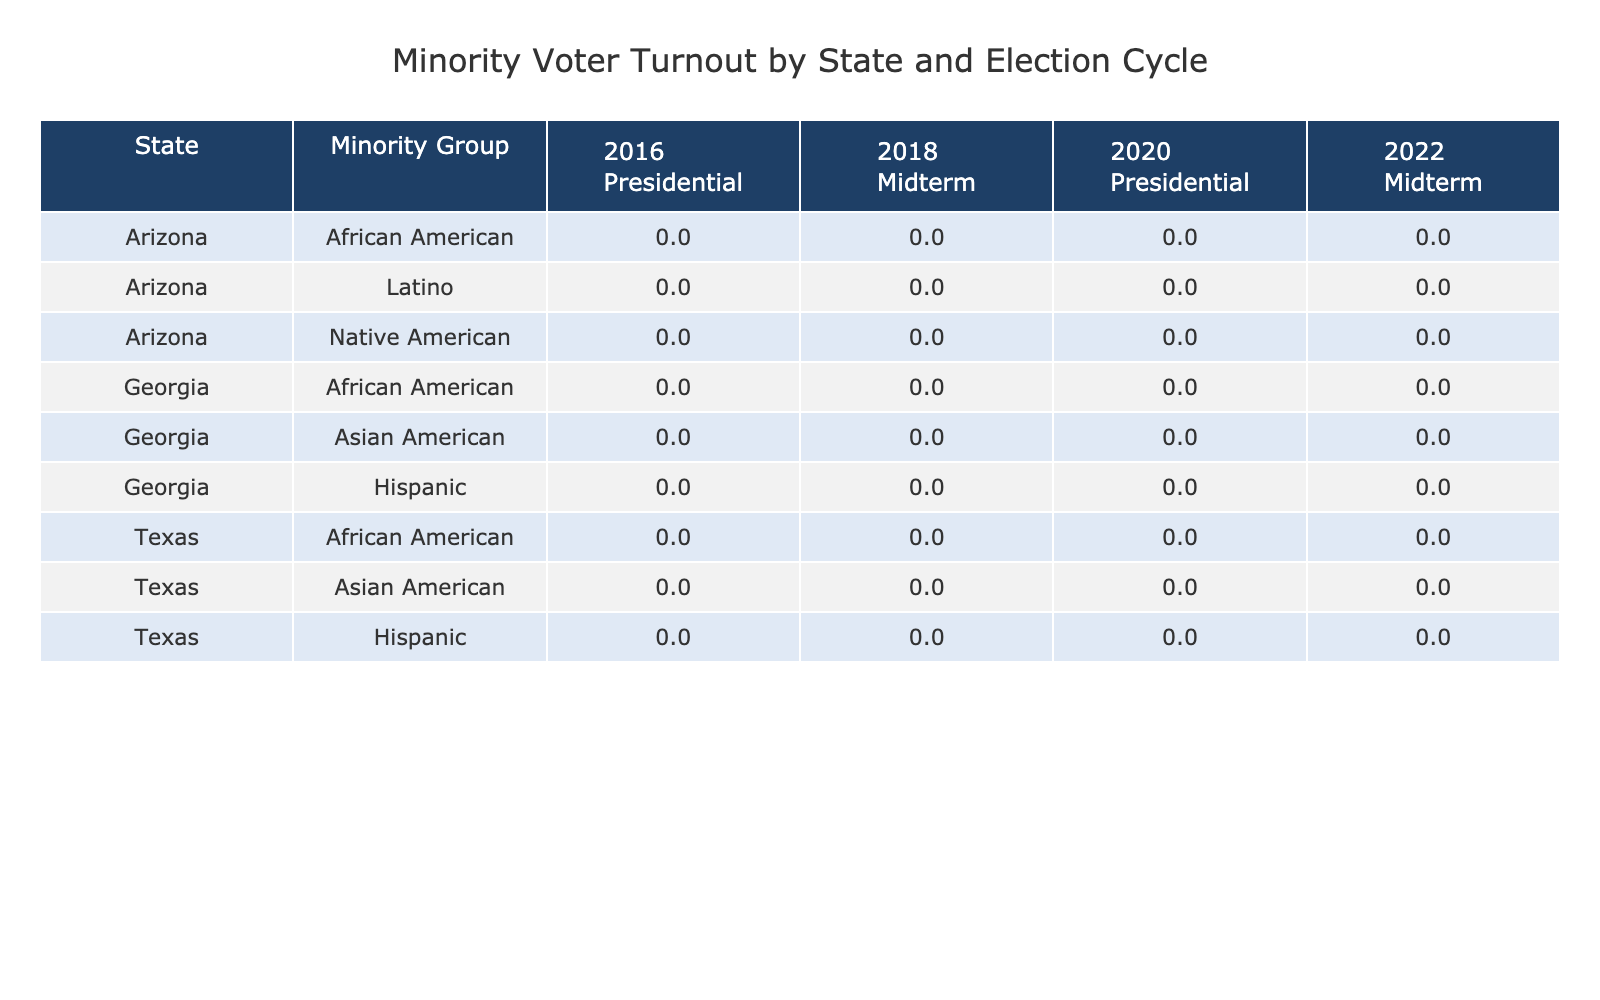What was the voter turnout percentage for African Americans in Georgia during the 2020 Presidential election? In the table, I locate the entry for Georgia, African American, and the 2020 Presidential election. The value listed is 66.4%.
Answer: 66.4% Which minority group had the lowest voter turnout in Arizona during the 2018 Midterm elections? I check the 2018 Midterm column for Arizona and find the following percentages: Latino (50.9%), Native American (47.1%), and African American (55.8%). The lowest percentage is for Native American at 47.1%.
Answer: Native American What is the difference in voter turnout for Hispanics in Texas between the 2016 Presidential election and the 2022 Midterm election? For Texas, the Hispanic voter turnout in 2016 is 53.4% and in 2022 is 49.3%. The difference is calculated by subtracting the two: 53.4% - 49.3% = 4.1%.
Answer: 4.1% Did the voter turnout for Asian Americans in Georgia increase from 2016 to 2020 for the Presidential elections? In the table, the Asian American voter turnout in Georgia for the 2016 Presidential election is 49.7% and for 2020 it is 54.2%. Since 54.2% is higher than 49.7%, it indicates an increase.
Answer: Yes What is the average voter turnout for African Americans in Texas across all years and election types listed? I extract the data for African Americans in Texas: 59.6% (2016 Presidential), 53.2% (2018 Midterm), 63.9% (2020 Presidential), and 56.7% (2022 Midterm). The total sum is 59.6 + 53.2 + 63.9 + 56.7 = 233.4%. There are 4 data points, so the average is 233.4% / 4 = 58.35%.
Answer: 58.35% 